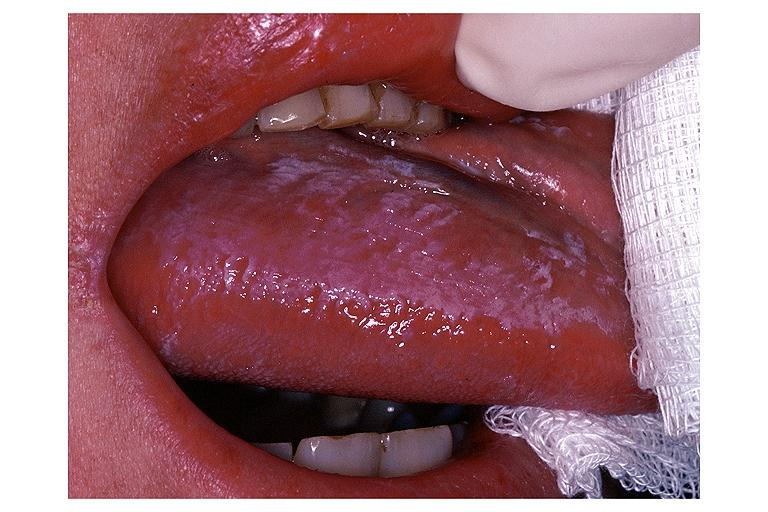does anthracotic pigment show oral hairy leukoplakia?
Answer the question using a single word or phrase. No 